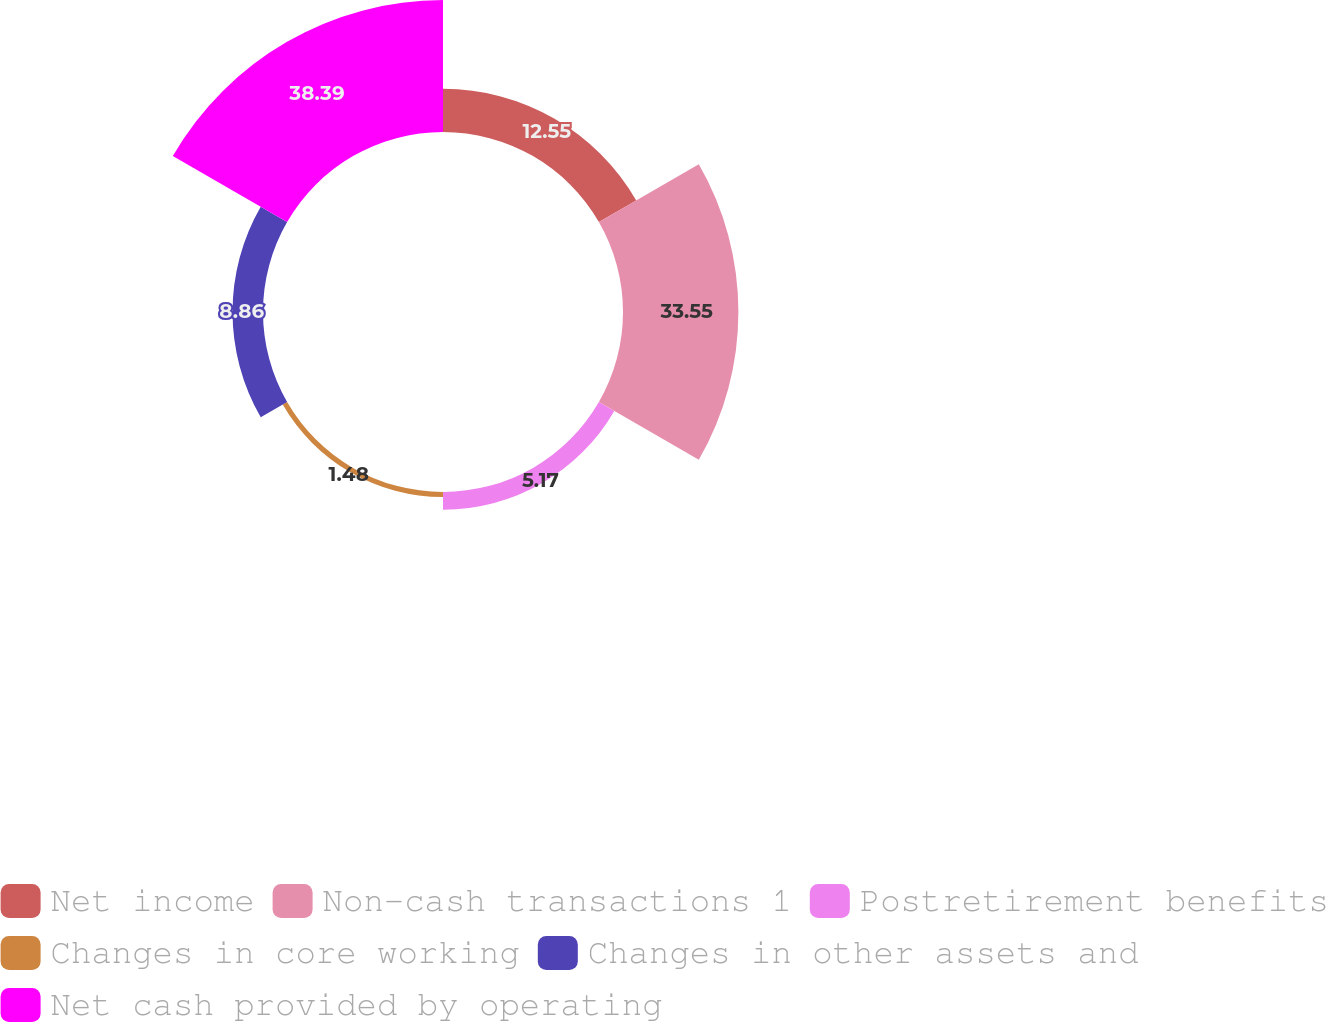Convert chart to OTSL. <chart><loc_0><loc_0><loc_500><loc_500><pie_chart><fcel>Net income<fcel>Non-cash transactions 1<fcel>Postretirement benefits<fcel>Changes in core working<fcel>Changes in other assets and<fcel>Net cash provided by operating<nl><fcel>12.55%<fcel>33.55%<fcel>5.17%<fcel>1.48%<fcel>8.86%<fcel>38.38%<nl></chart> 